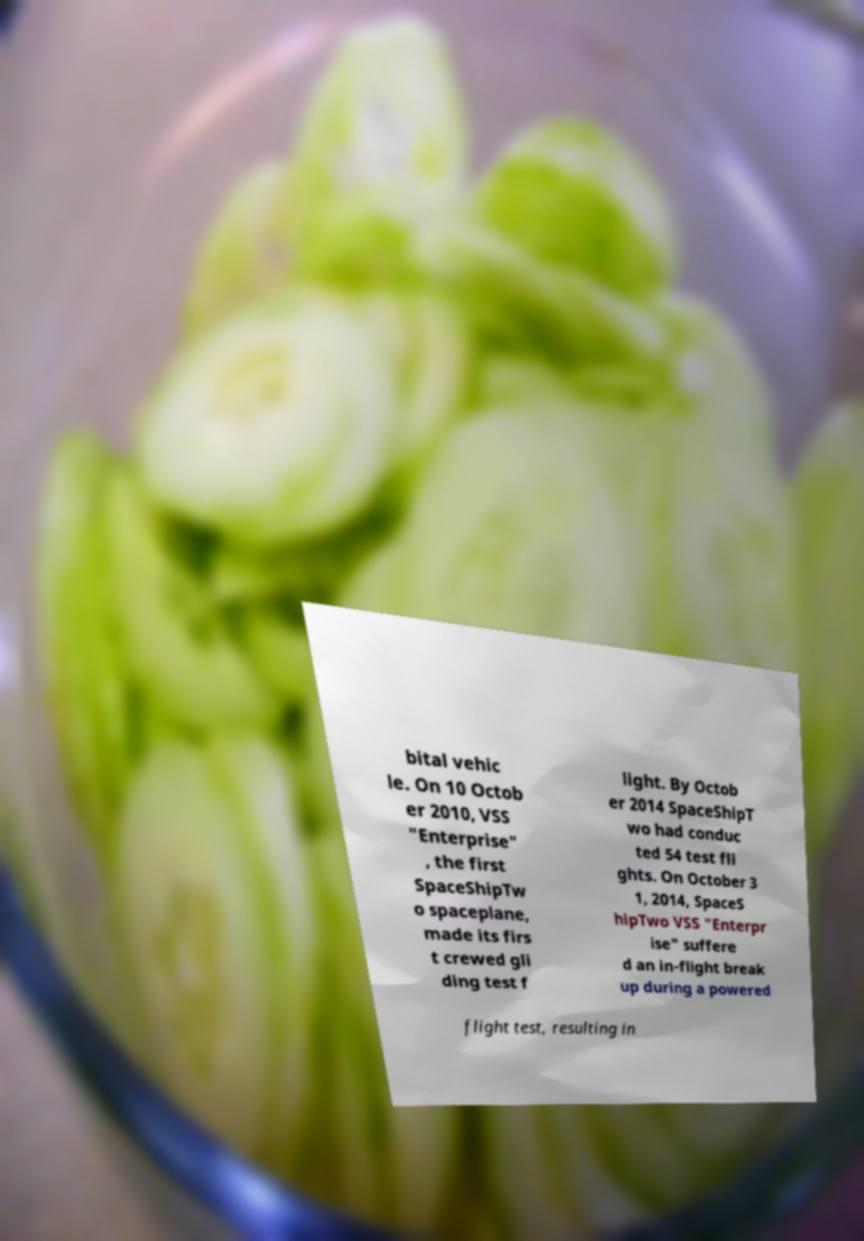For documentation purposes, I need the text within this image transcribed. Could you provide that? bital vehic le. On 10 Octob er 2010, VSS "Enterprise" , the first SpaceShipTw o spaceplane, made its firs t crewed gli ding test f light. By Octob er 2014 SpaceShipT wo had conduc ted 54 test fli ghts. On October 3 1, 2014, SpaceS hipTwo VSS "Enterpr ise" suffere d an in-flight break up during a powered flight test, resulting in 